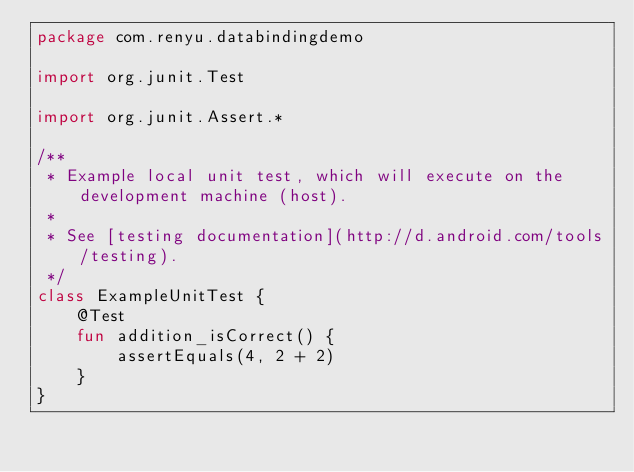Convert code to text. <code><loc_0><loc_0><loc_500><loc_500><_Kotlin_>package com.renyu.databindingdemo

import org.junit.Test

import org.junit.Assert.*

/**
 * Example local unit test, which will execute on the development machine (host).
 *
 * See [testing documentation](http://d.android.com/tools/testing).
 */
class ExampleUnitTest {
    @Test
    fun addition_isCorrect() {
        assertEquals(4, 2 + 2)
    }
}
</code> 